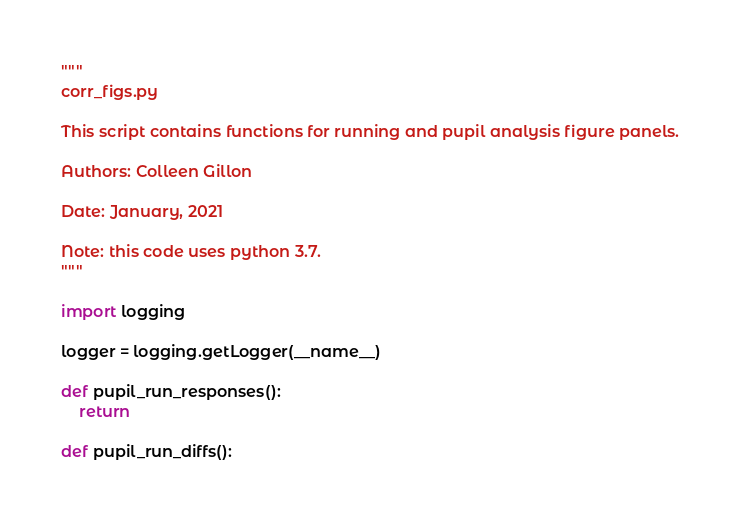Convert code to text. <code><loc_0><loc_0><loc_500><loc_500><_Python_>"""
corr_figs.py

This script contains functions for running and pupil analysis figure panels.

Authors: Colleen Gillon

Date: January, 2021

Note: this code uses python 3.7.
"""

import logging

logger = logging.getLogger(__name__)

def pupil_run_responses():
    return
    
def pupil_run_diffs():</code> 